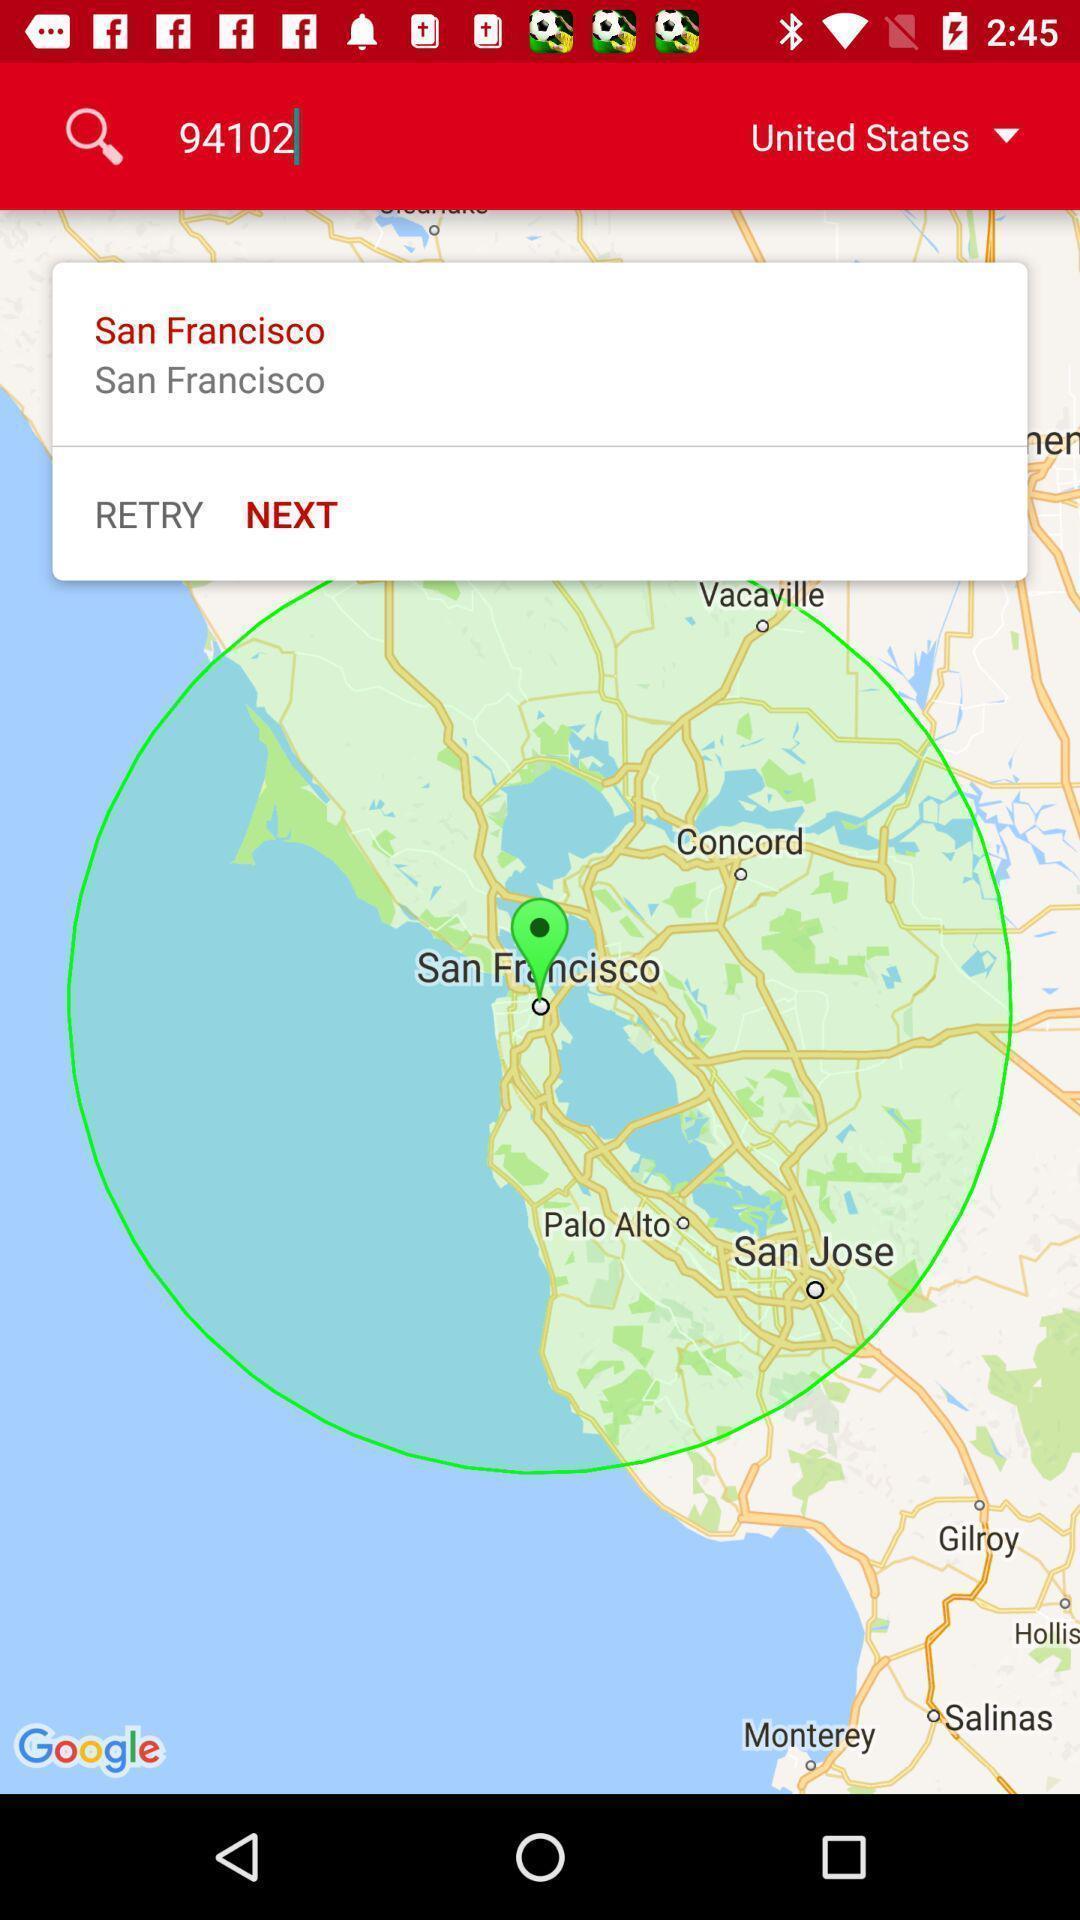What is the overall content of this screenshot? Search the location by using the code. 